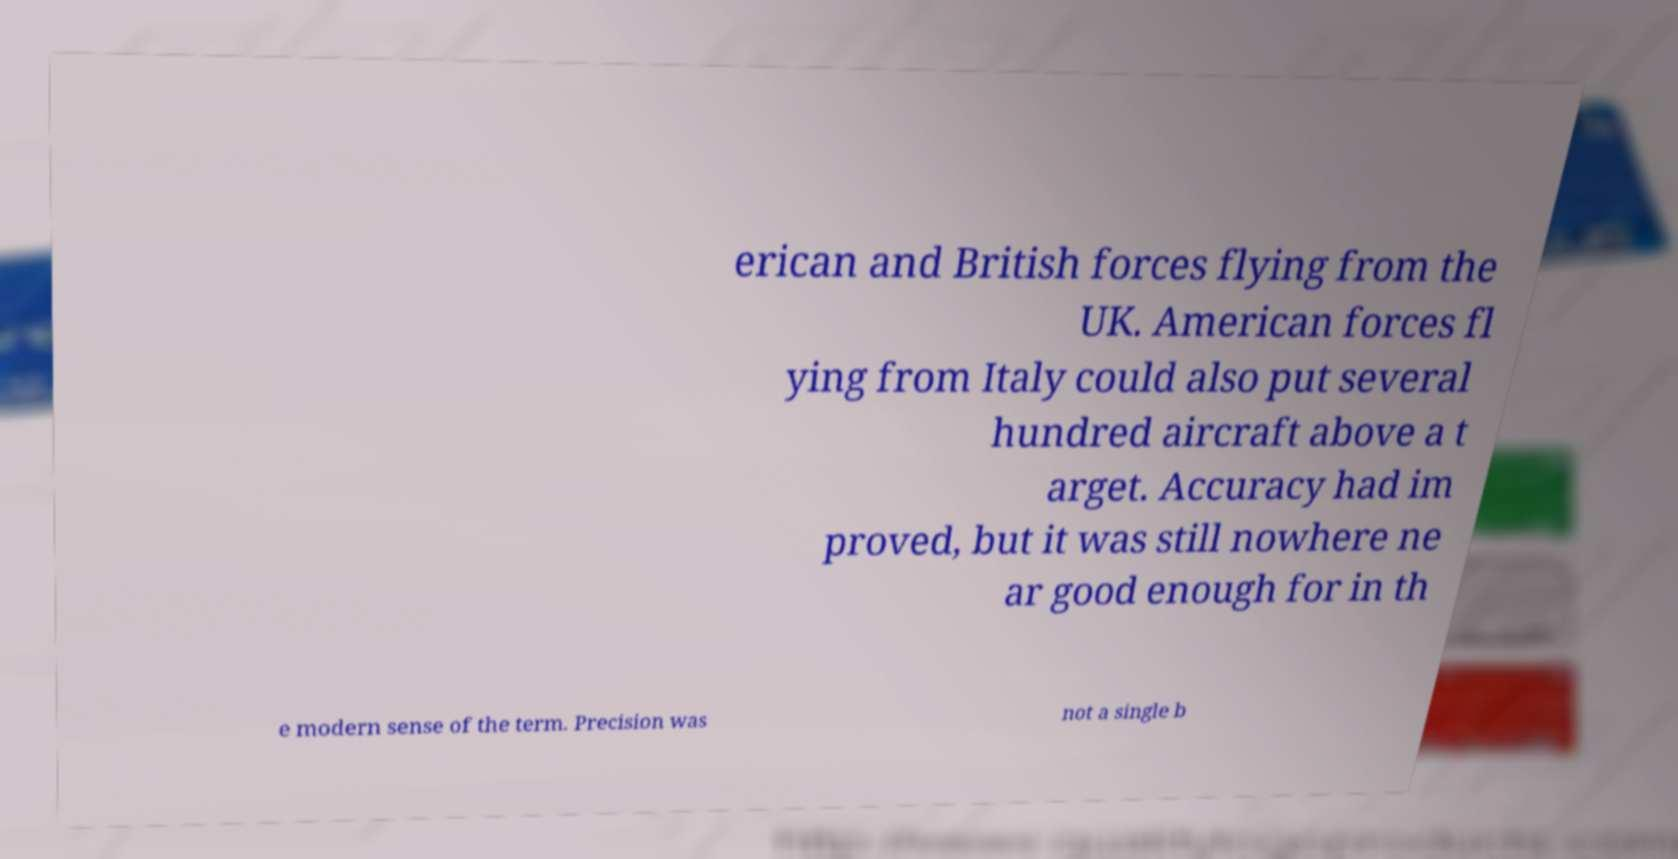Please identify and transcribe the text found in this image. erican and British forces flying from the UK. American forces fl ying from Italy could also put several hundred aircraft above a t arget. Accuracy had im proved, but it was still nowhere ne ar good enough for in th e modern sense of the term. Precision was not a single b 